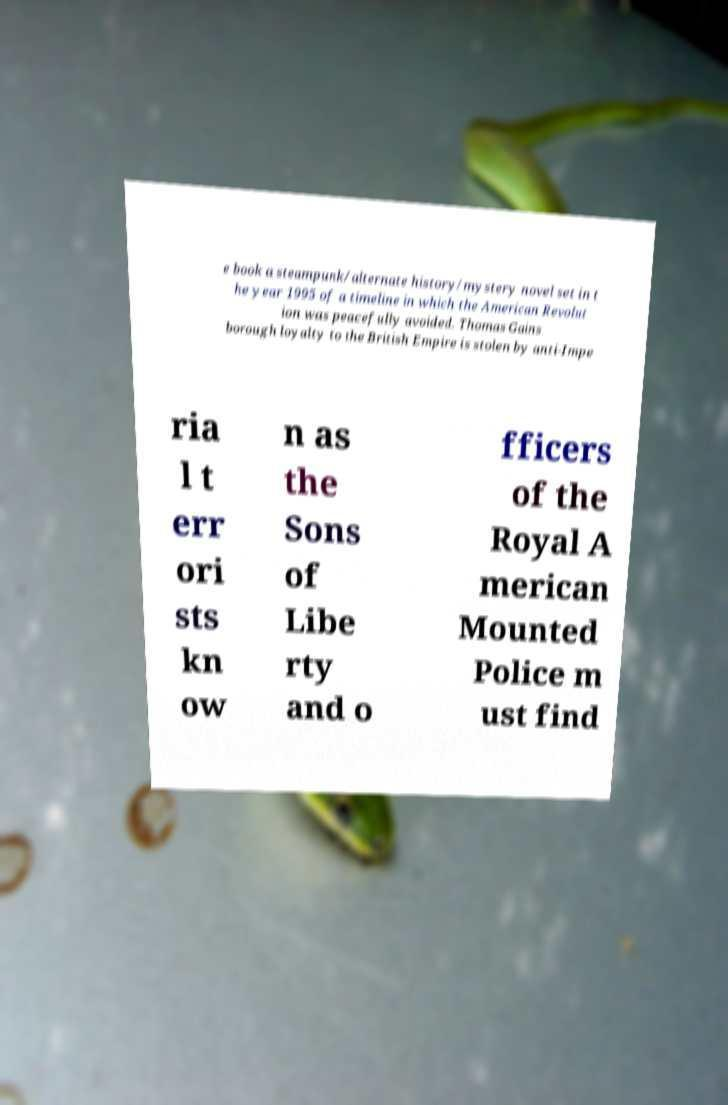There's text embedded in this image that I need extracted. Can you transcribe it verbatim? e book a steampunk/alternate history/mystery novel set in t he year 1995 of a timeline in which the American Revolut ion was peacefully avoided. Thomas Gains borough loyalty to the British Empire is stolen by anti-Impe ria l t err ori sts kn ow n as the Sons of Libe rty and o fficers of the Royal A merican Mounted Police m ust find 